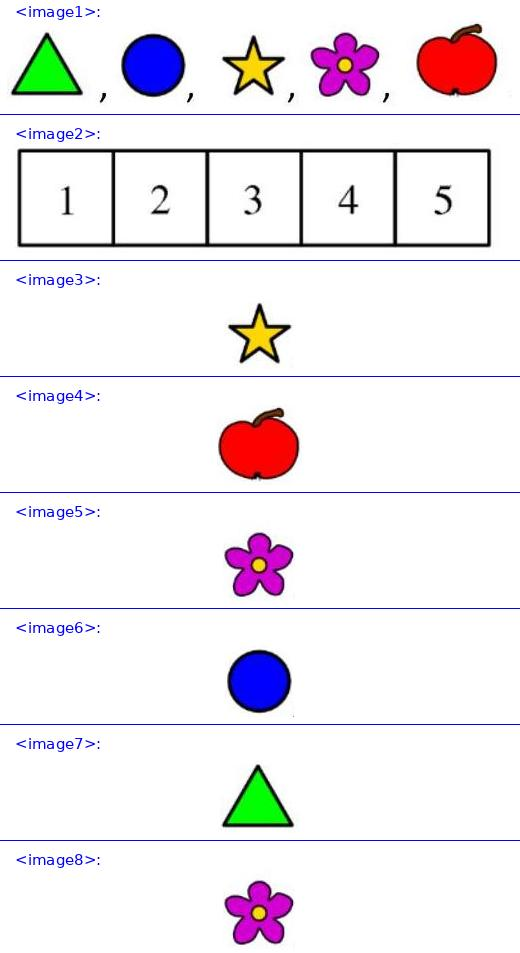Eva has the 5 stickers shown: . She stuck one of them on each of the 5 squares of this board <image2> so that <image3> is not on square 5, <image4> is on square 1, and <image5> is adjacent to <image6> and <image7>. On which square did Eva stick <image5>? Answer is 4. 